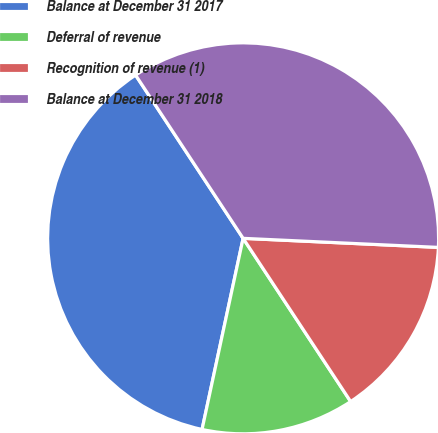<chart> <loc_0><loc_0><loc_500><loc_500><pie_chart><fcel>Balance at December 31 2017<fcel>Deferral of revenue<fcel>Recognition of revenue (1)<fcel>Balance at December 31 2018<nl><fcel>37.36%<fcel>12.64%<fcel>14.99%<fcel>35.01%<nl></chart> 